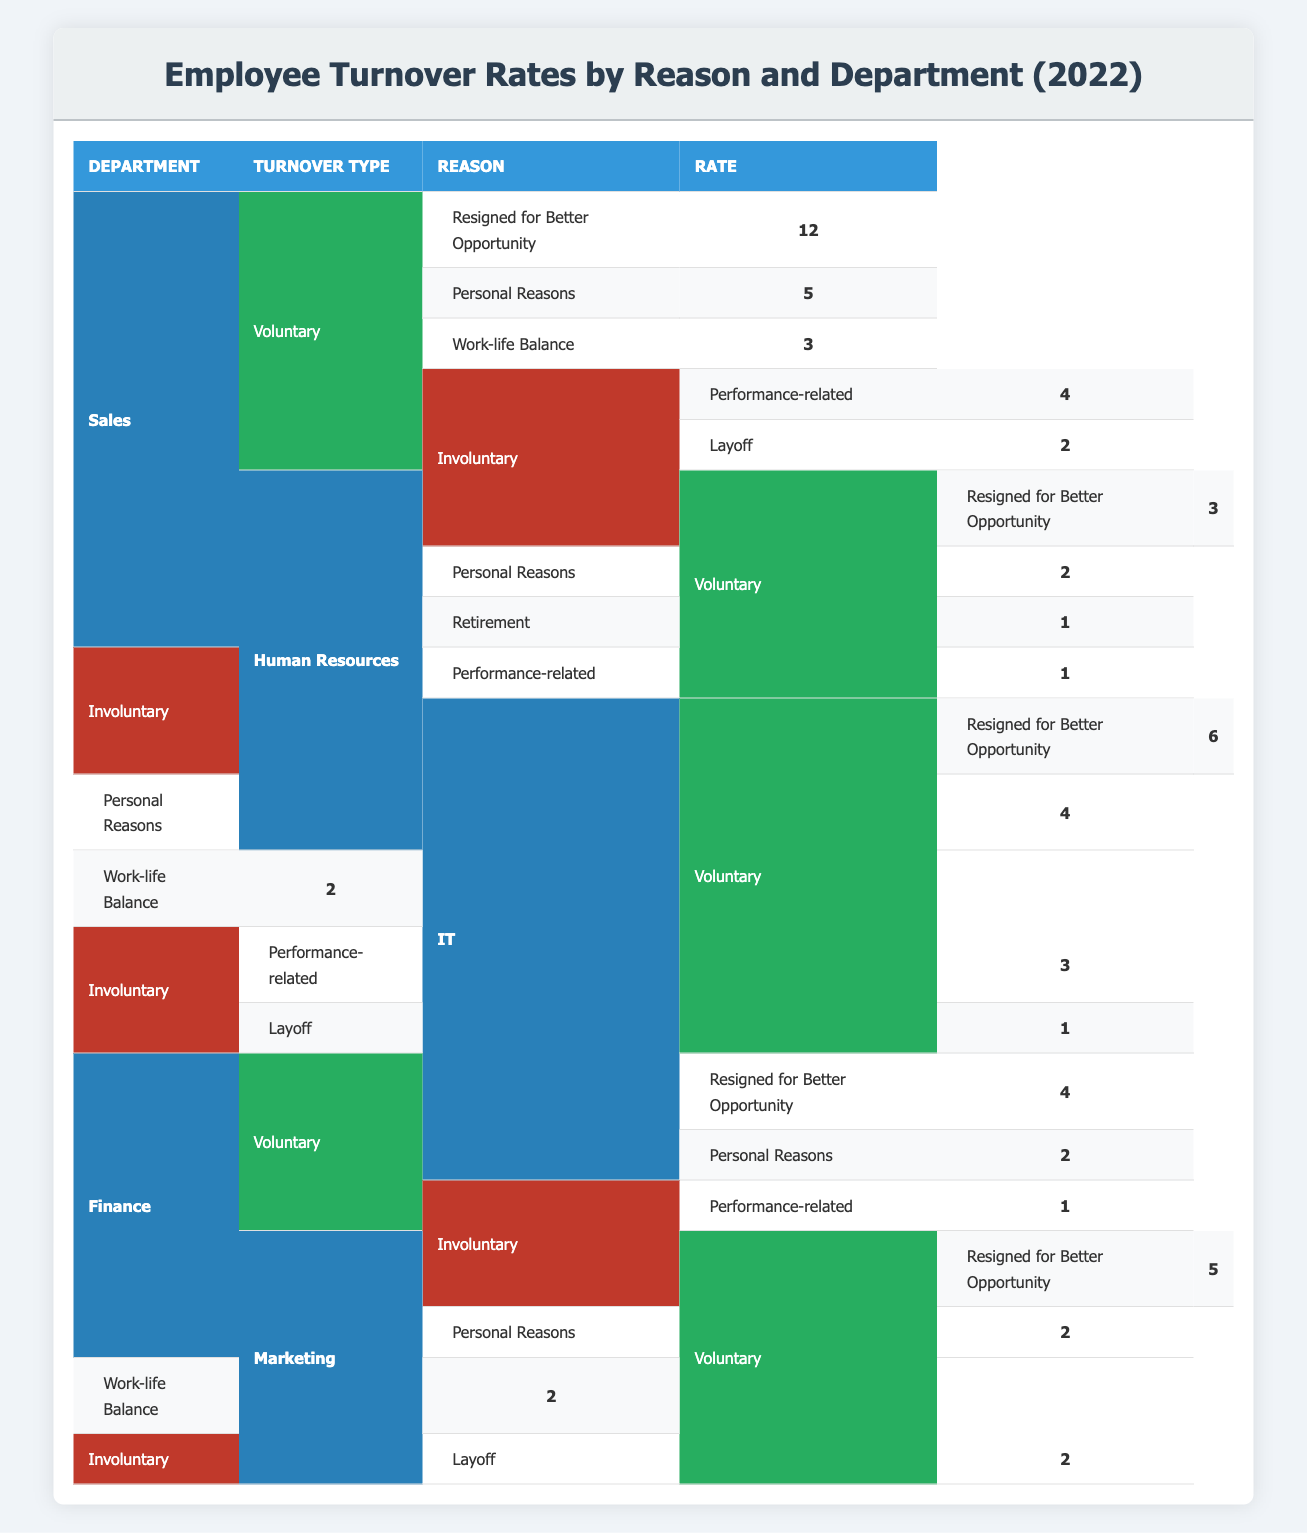What is the turnover rate for "Resigned for Better Opportunity" in the Sales department? From the table, under the Sales department and Voluntary turnover type, the rate for the reason "Resigned for Better Opportunity" is 12.
Answer: 12 How many total voluntary turnover cases were recorded in the IT department? In the IT department, the voluntary turnover cases are: "Resigned for Better Opportunity" (6), "Personal Reasons" (4), and "Work-life Balance" (2). Summing these gives 6 + 4 + 2 = 12.
Answer: 12 Did the Finance department have any involuntary turnover rates due to layoffs? Checking the table for the Finance department, it shows there is 1 case of "Performance-related" involuntary turnover but no mention of layoffs under this department. Therefore, there are no layoffs in the Finance department.
Answer: No What is the total turnover rate for the Human Resources department? In the Human Resources department, all turnover reasons (Voluntary and Involuntary) add up: Voluntary (3 + 2 + 1) = 6 and Involuntary (1) = 1. Overall sum is 6 + 1 = 7.
Answer: 7 Which department had the highest rate of turnover due to "Personal Reasons"? Looking through the table, for "Personal Reasons," the rates are: Sales (5), Human Resources (2), IT (4), Finance (2), and Marketing (2). The highest is from the Sales department at a rate of 5.
Answer: Sales What is the difference in voluntary turnover rates between the IT department and the Marketing department? From the table, in the IT department, the voluntary turnover rates are (6 + 4 + 2) = 12. In the Marketing department, they are (5 + 2 + 2) = 9. Therefore, the difference is 12 - 9 = 3.
Answer: 3 Is it true that the Human Resources department had more voluntary turnover cases than involuntary turnover cases? For the Human Resources department, the voluntary turnover counts to 6 (3 + 2 + 1) while the involuntary turnover has only 1. Since 6 is greater than 1, the statement is true.
Answer: Yes What is the average turnover rate for all departments due to "Resigned for Better Opportunity"? The rates for "Resigned for Better Opportunity" in various departments are: Sales (12), Human Resources (3), IT (6), Finance (4), and Marketing (5). The total is 12 + 3 + 6 + 4 + 5 = 30 and there are 5 departments, thus the average is 30 / 5 = 6.
Answer: 6 